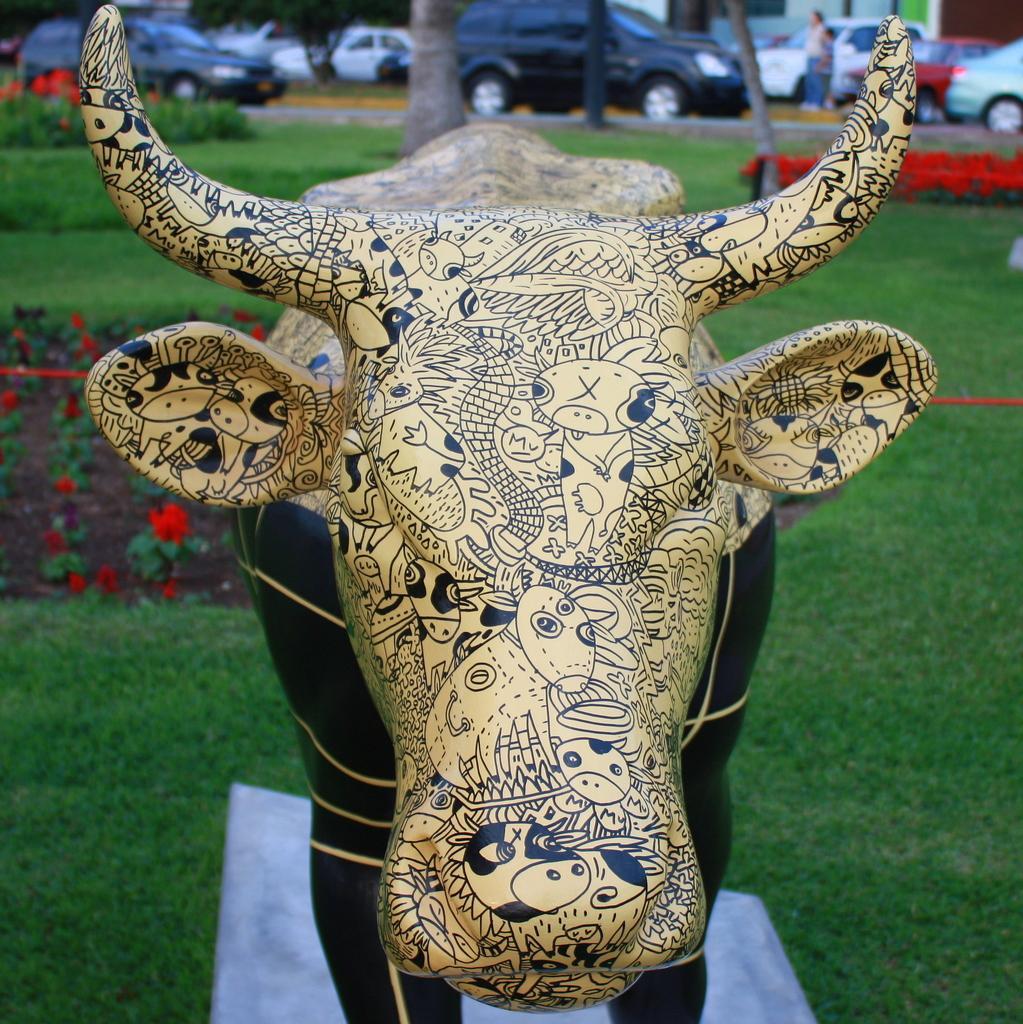How would you summarize this image in a sentence or two? This image consists of a bull. At the bottom, there is green grass. In the background, we can see many flowers in red color. And there are cars parked on the road. 